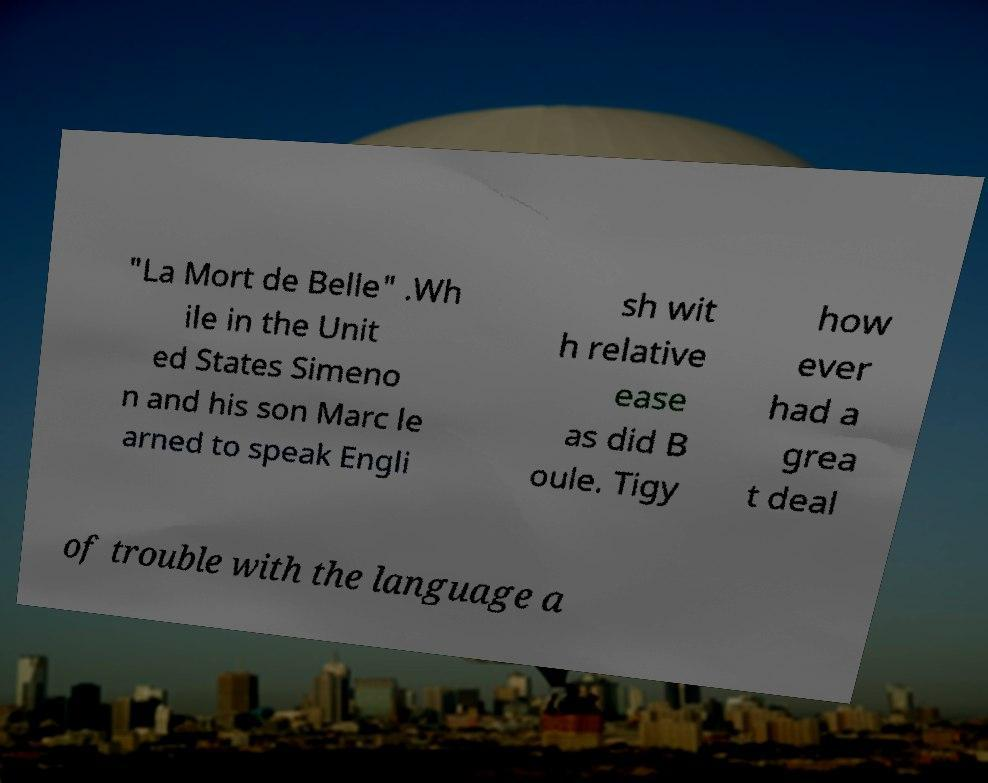Could you assist in decoding the text presented in this image and type it out clearly? "La Mort de Belle" .Wh ile in the Unit ed States Simeno n and his son Marc le arned to speak Engli sh wit h relative ease as did B oule. Tigy how ever had a grea t deal of trouble with the language a 